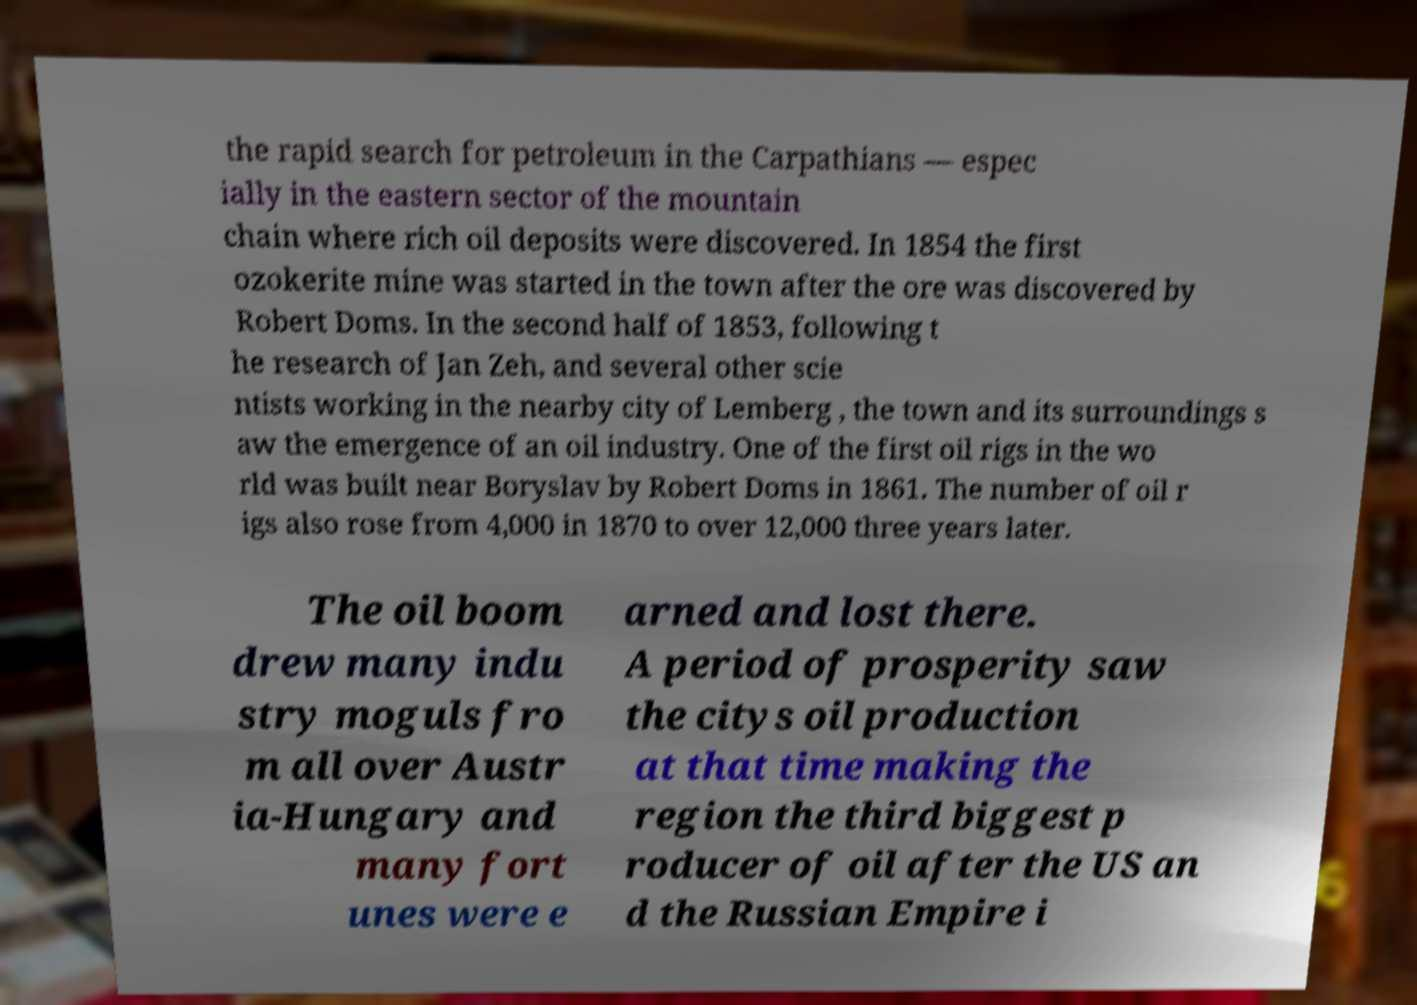Could you assist in decoding the text presented in this image and type it out clearly? the rapid search for petroleum in the Carpathians — espec ially in the eastern sector of the mountain chain where rich oil deposits were discovered. In 1854 the first ozokerite mine was started in the town after the ore was discovered by Robert Doms. In the second half of 1853, following t he research of Jan Zeh, and several other scie ntists working in the nearby city of Lemberg , the town and its surroundings s aw the emergence of an oil industry. One of the first oil rigs in the wo rld was built near Boryslav by Robert Doms in 1861. The number of oil r igs also rose from 4,000 in 1870 to over 12,000 three years later. The oil boom drew many indu stry moguls fro m all over Austr ia-Hungary and many fort unes were e arned and lost there. A period of prosperity saw the citys oil production at that time making the region the third biggest p roducer of oil after the US an d the Russian Empire i 